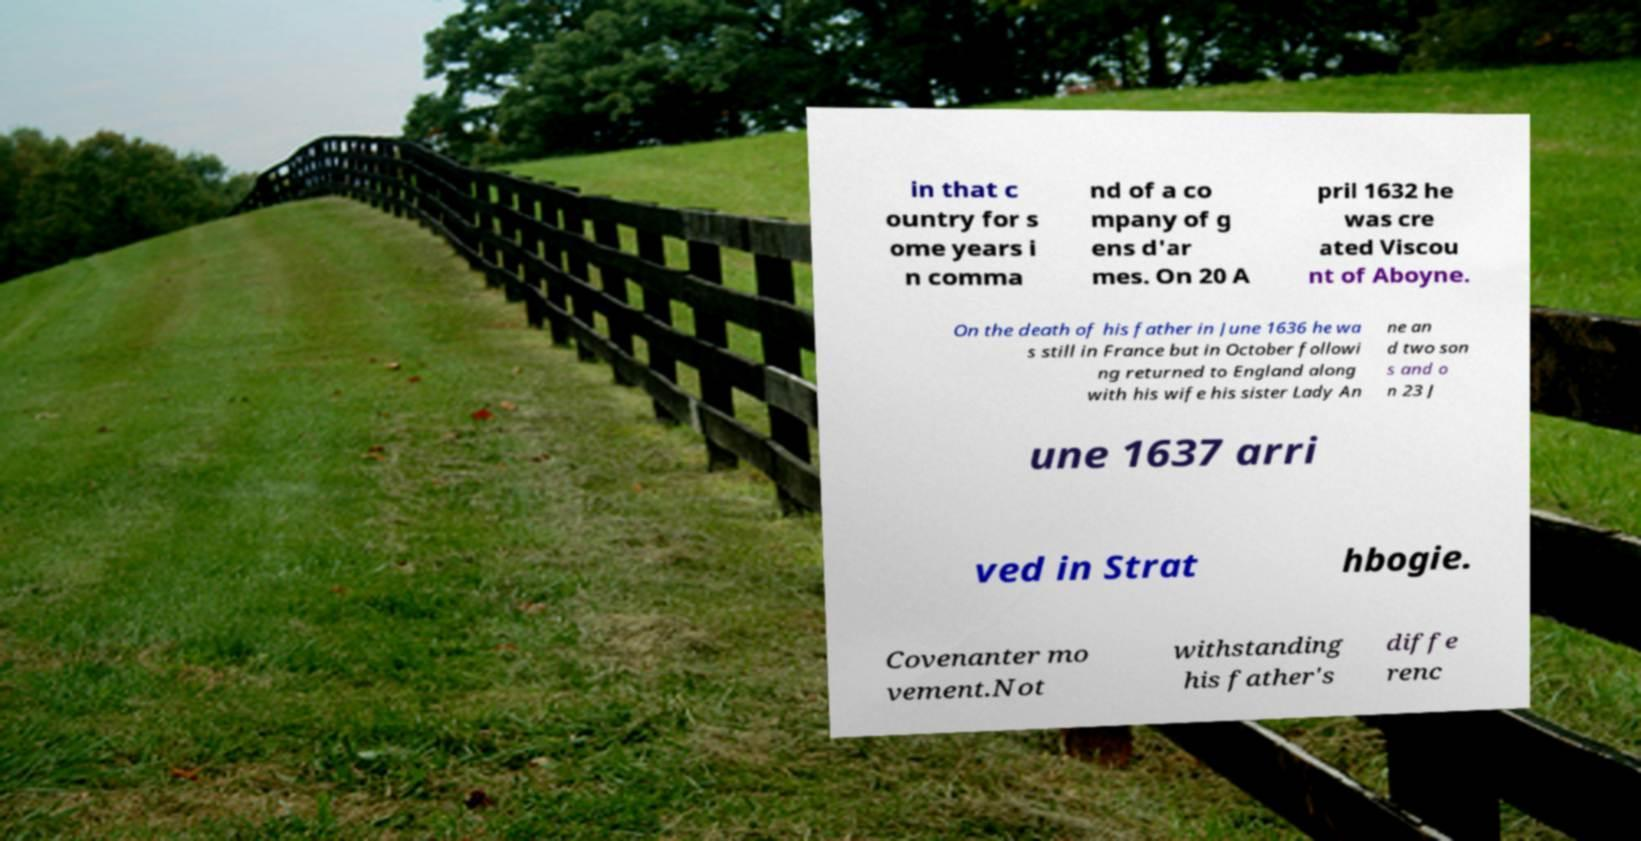I need the written content from this picture converted into text. Can you do that? in that c ountry for s ome years i n comma nd of a co mpany of g ens d'ar mes. On 20 A pril 1632 he was cre ated Viscou nt of Aboyne. On the death of his father in June 1636 he wa s still in France but in October followi ng returned to England along with his wife his sister Lady An ne an d two son s and o n 23 J une 1637 arri ved in Strat hbogie. Covenanter mo vement.Not withstanding his father's diffe renc 